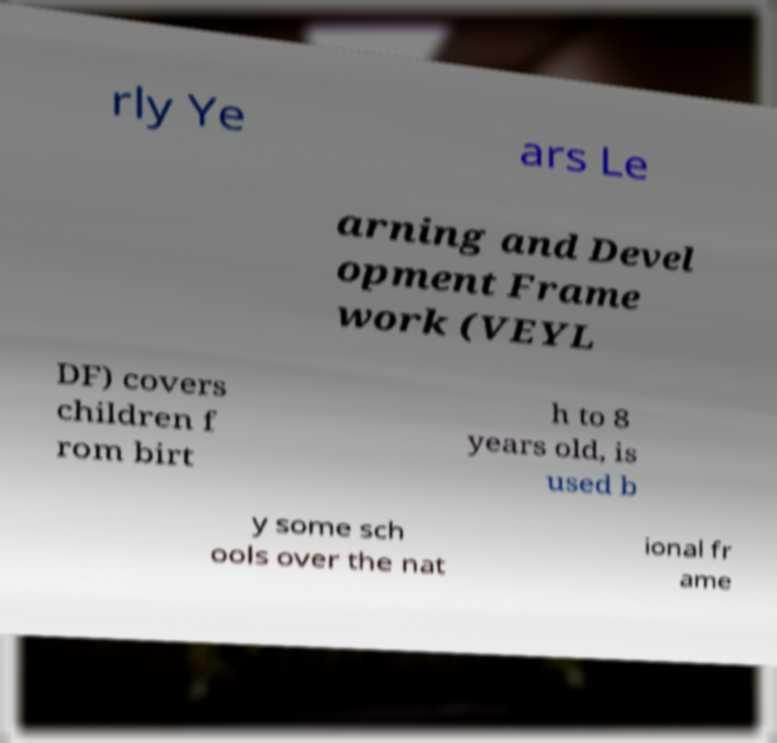What messages or text are displayed in this image? I need them in a readable, typed format. rly Ye ars Le arning and Devel opment Frame work (VEYL DF) covers children f rom birt h to 8 years old, is used b y some sch ools over the nat ional fr ame 